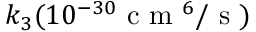Convert formula to latex. <formula><loc_0><loc_0><loc_500><loc_500>k _ { 3 } ( 1 0 ^ { - 3 0 } c m ^ { 6 } / s )</formula> 